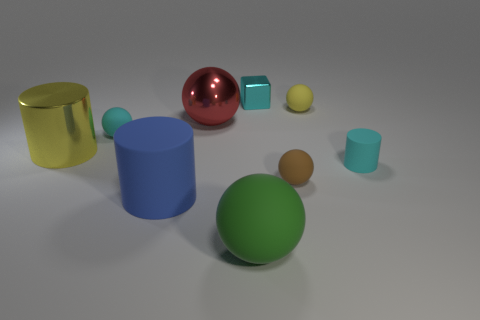Subtract all metal cylinders. How many cylinders are left? 2 Add 1 tiny yellow rubber cylinders. How many objects exist? 10 Subtract all green balls. How many balls are left? 4 Subtract 1 cylinders. How many cylinders are left? 2 Add 1 brown matte things. How many brown matte things are left? 2 Add 9 small cyan blocks. How many small cyan blocks exist? 10 Subtract 1 cyan blocks. How many objects are left? 8 Subtract all cubes. How many objects are left? 8 Subtract all red cylinders. Subtract all brown blocks. How many cylinders are left? 3 Subtract all blue objects. Subtract all tiny yellow spheres. How many objects are left? 7 